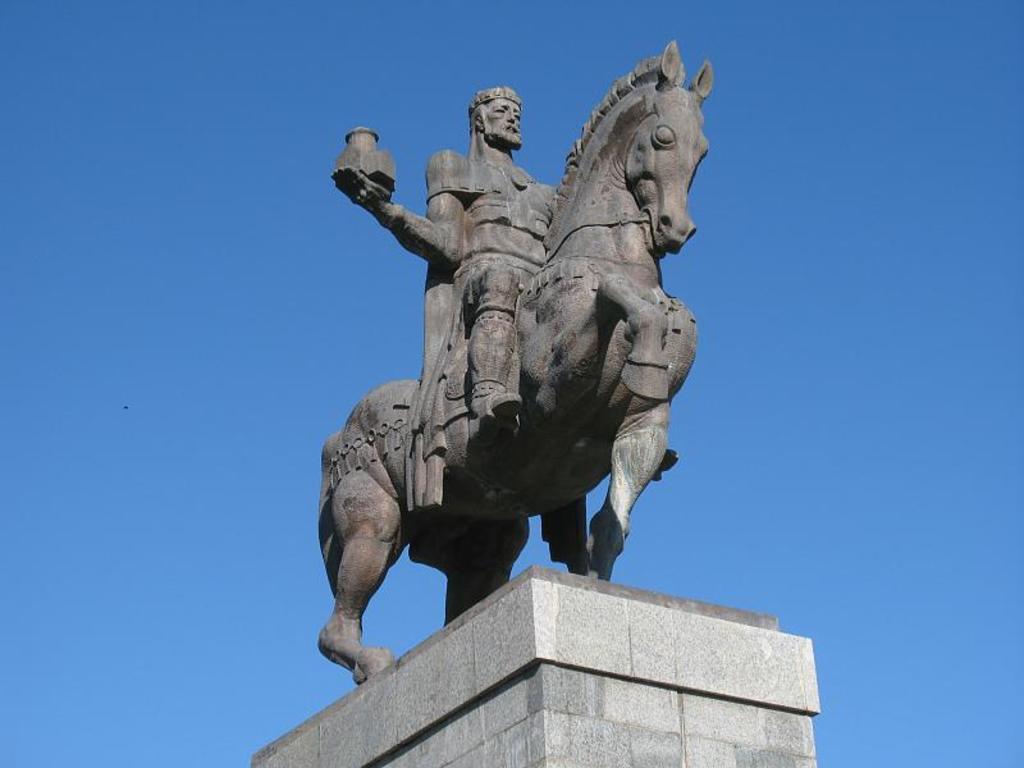Please provide a concise description of this image. In this image we can see a statue of a person and a horse. We can see the sky in the image. 